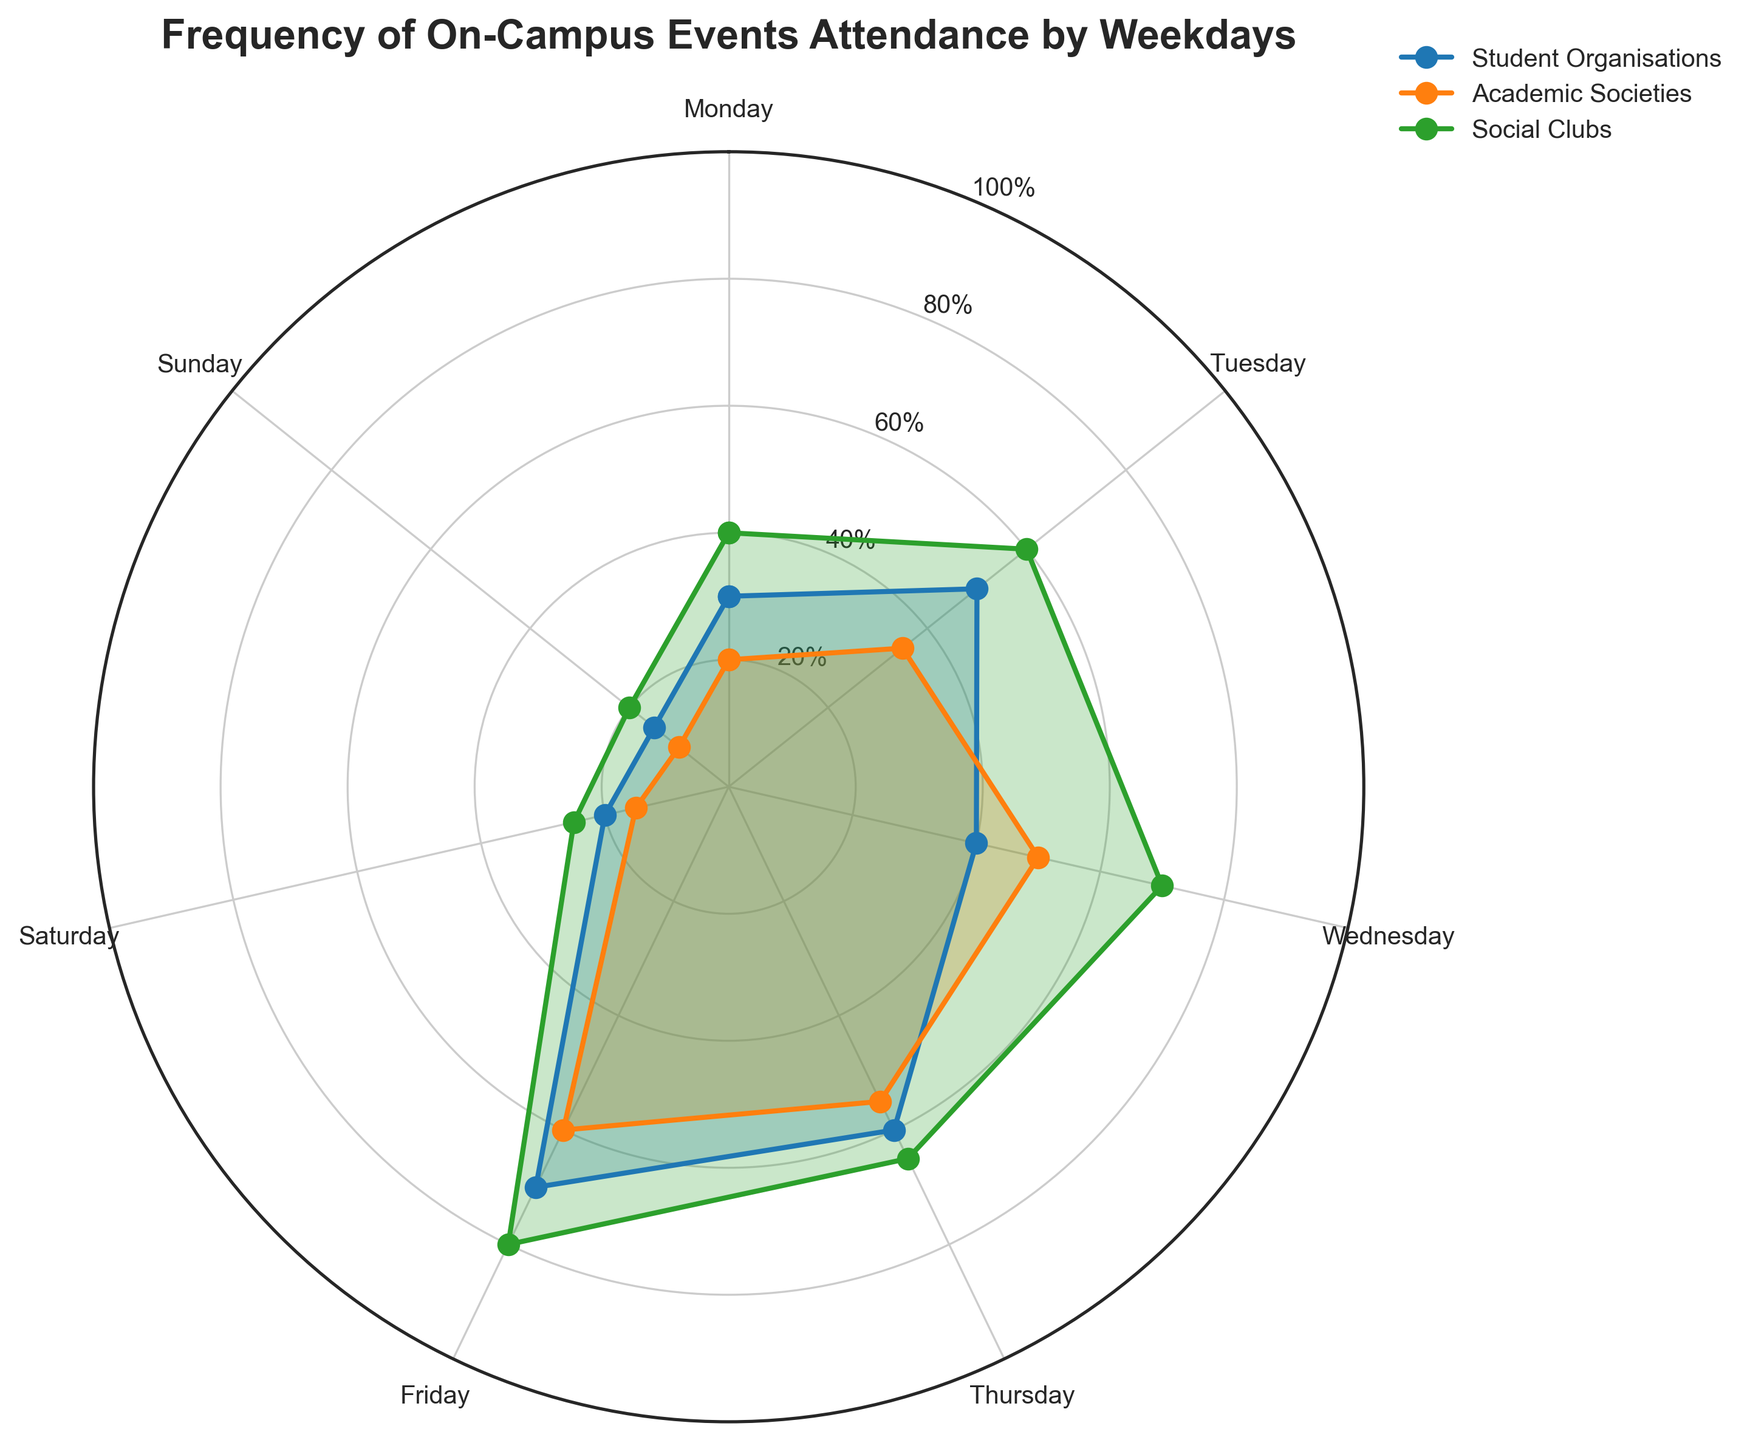How many days are displayed on the radar chart? The radar chart displays data for each day of the week from Monday to Sunday. To determine the number of days, simply count the unique categories labeled on the chart. There are seven days represented: Monday, Tuesday, Wednesday, Thursday, Friday, Saturday, and Sunday.
Answer: Seven Which day shows the highest attendance for Social Clubs? To find this, locate the Social Clubs series on the radar chart and identify the day with the maximum height from the center of the chart. Based on the data, Friday shows the peak value for Social Clubs at 80.
Answer: Friday What is the discrepancy in attendance for Academic Societies between Thursday and Sunday? Look at the specific points for Academic Societies on both Thursday and Sunday. On Thursday, the attendance is 55; on Sunday, it's 10. Calculate the difference: 55 - 10 = 45.
Answer: 45 Compare the attendance for Student Organisations on Monday and Wednesday. Which day has higher attendance and by how much? Identify the values for Student Organisations on Monday and Wednesday. Monday has 30, and Wednesday has 40. Subtract Monday's value from Wednesday's value: 40 - 30 = 10. Thus, Wednesday has higher attendance by 10.
Answer: Wednesday by 10 What is the average attendance for Social Clubs across the weekdays? To calculate this, sum the attendance values for Social Clubs from Monday to Friday and then divide by 5. The values are 40, 60, 70, 65, 80. The sum is 40 + 60 + 70 + 65 + 80 = 315. The average is 315 / 5 = 63.
Answer: 63 Looking at the radar chart, on which day(s) is attendance the lowest for all groups combined? For this, sum the attendance values of Student Organisations, Academic Societies, and Social Clubs for each day, and identify the day with the smallest total. Calculate the following sums: Monday (30+20+40=90), Tuesday (50+35+60=145), Wednesday (40+50+70=160), Thursday (60+55+65=180), Friday (70+60+80=210), Saturday (20+15+25=60), Sunday (15+10+20=45). The smallest total is Sunday with 45.
Answer: Sunday During which day is the attendance consistently highest across all three groups? Identify the trends for each group. If any day consistently appears near the highest values for all groups, that day generally would be the highest. The peak attendance values for each are: Student Organisations - Friday (70), Academic Societies - Friday (60), Social Clubs - Friday (80). All occurring on Friday.
Answer: Friday What is the total attendance for Academic Societies throughout the week? Sum the attendance values for Academic Societies from Monday to Sunday: 20 + 35 + 50 + 55 + 60 + 15 + 10 = 245.
Answer: 245 